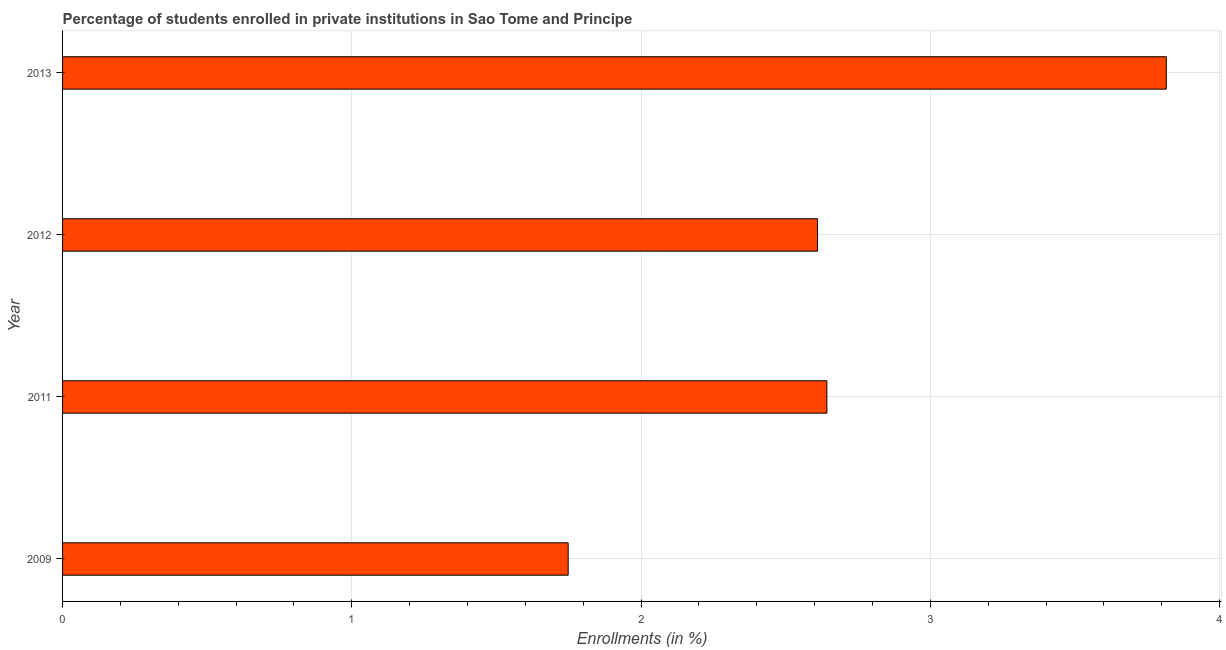Does the graph contain grids?
Provide a succinct answer. Yes. What is the title of the graph?
Provide a short and direct response. Percentage of students enrolled in private institutions in Sao Tome and Principe. What is the label or title of the X-axis?
Your answer should be compact. Enrollments (in %). What is the enrollments in private institutions in 2011?
Your answer should be compact. 2.64. Across all years, what is the maximum enrollments in private institutions?
Give a very brief answer. 3.82. Across all years, what is the minimum enrollments in private institutions?
Give a very brief answer. 1.75. In which year was the enrollments in private institutions maximum?
Provide a short and direct response. 2013. What is the sum of the enrollments in private institutions?
Ensure brevity in your answer.  10.82. What is the difference between the enrollments in private institutions in 2011 and 2013?
Keep it short and to the point. -1.17. What is the average enrollments in private institutions per year?
Your answer should be very brief. 2.7. What is the median enrollments in private institutions?
Your answer should be very brief. 2.63. What is the ratio of the enrollments in private institutions in 2009 to that in 2012?
Ensure brevity in your answer.  0.67. Is the enrollments in private institutions in 2011 less than that in 2013?
Your answer should be compact. Yes. What is the difference between the highest and the second highest enrollments in private institutions?
Offer a very short reply. 1.17. Is the sum of the enrollments in private institutions in 2009 and 2011 greater than the maximum enrollments in private institutions across all years?
Provide a short and direct response. Yes. What is the difference between the highest and the lowest enrollments in private institutions?
Offer a very short reply. 2.07. How many bars are there?
Give a very brief answer. 4. Are all the bars in the graph horizontal?
Provide a short and direct response. Yes. What is the Enrollments (in %) in 2009?
Your answer should be compact. 1.75. What is the Enrollments (in %) in 2011?
Ensure brevity in your answer.  2.64. What is the Enrollments (in %) of 2012?
Ensure brevity in your answer.  2.61. What is the Enrollments (in %) in 2013?
Make the answer very short. 3.82. What is the difference between the Enrollments (in %) in 2009 and 2011?
Offer a very short reply. -0.89. What is the difference between the Enrollments (in %) in 2009 and 2012?
Your response must be concise. -0.86. What is the difference between the Enrollments (in %) in 2009 and 2013?
Provide a short and direct response. -2.07. What is the difference between the Enrollments (in %) in 2011 and 2012?
Your answer should be compact. 0.03. What is the difference between the Enrollments (in %) in 2011 and 2013?
Offer a terse response. -1.17. What is the difference between the Enrollments (in %) in 2012 and 2013?
Make the answer very short. -1.21. What is the ratio of the Enrollments (in %) in 2009 to that in 2011?
Offer a very short reply. 0.66. What is the ratio of the Enrollments (in %) in 2009 to that in 2012?
Make the answer very short. 0.67. What is the ratio of the Enrollments (in %) in 2009 to that in 2013?
Offer a terse response. 0.46. What is the ratio of the Enrollments (in %) in 2011 to that in 2013?
Provide a short and direct response. 0.69. What is the ratio of the Enrollments (in %) in 2012 to that in 2013?
Provide a succinct answer. 0.68. 